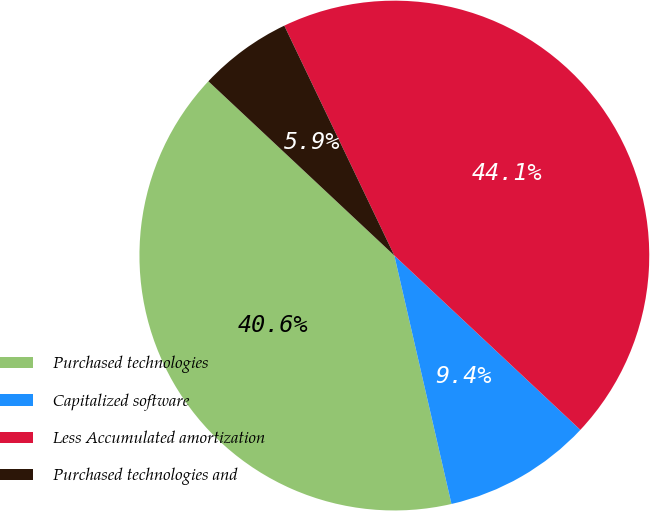Convert chart. <chart><loc_0><loc_0><loc_500><loc_500><pie_chart><fcel>Purchased technologies<fcel>Capitalized software<fcel>Less Accumulated amortization<fcel>Purchased technologies and<nl><fcel>40.58%<fcel>9.42%<fcel>44.09%<fcel>5.91%<nl></chart> 